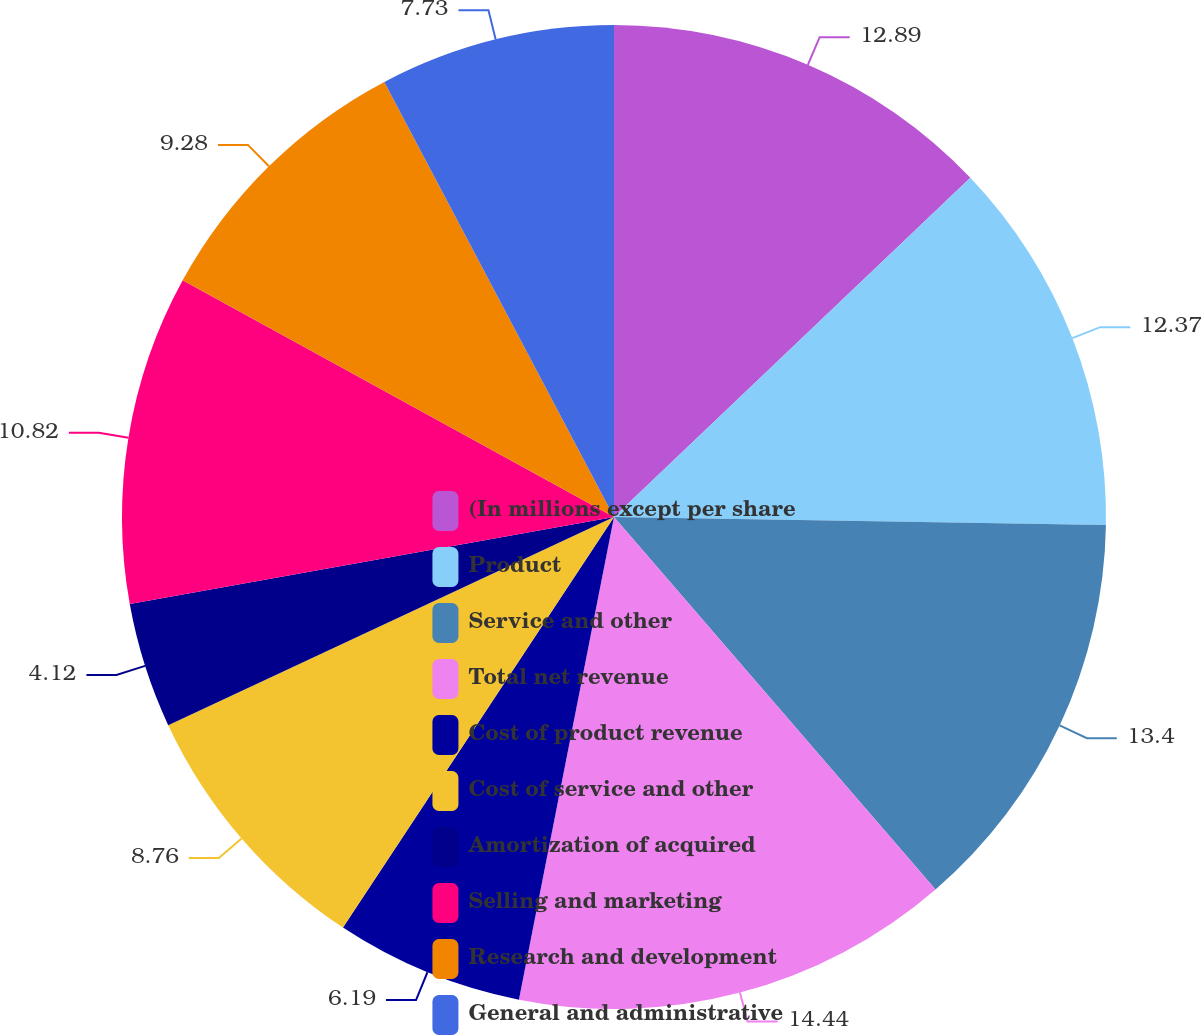Convert chart to OTSL. <chart><loc_0><loc_0><loc_500><loc_500><pie_chart><fcel>(In millions except per share<fcel>Product<fcel>Service and other<fcel>Total net revenue<fcel>Cost of product revenue<fcel>Cost of service and other<fcel>Amortization of acquired<fcel>Selling and marketing<fcel>Research and development<fcel>General and administrative<nl><fcel>12.89%<fcel>12.37%<fcel>13.4%<fcel>14.43%<fcel>6.19%<fcel>8.76%<fcel>4.12%<fcel>10.82%<fcel>9.28%<fcel>7.73%<nl></chart> 